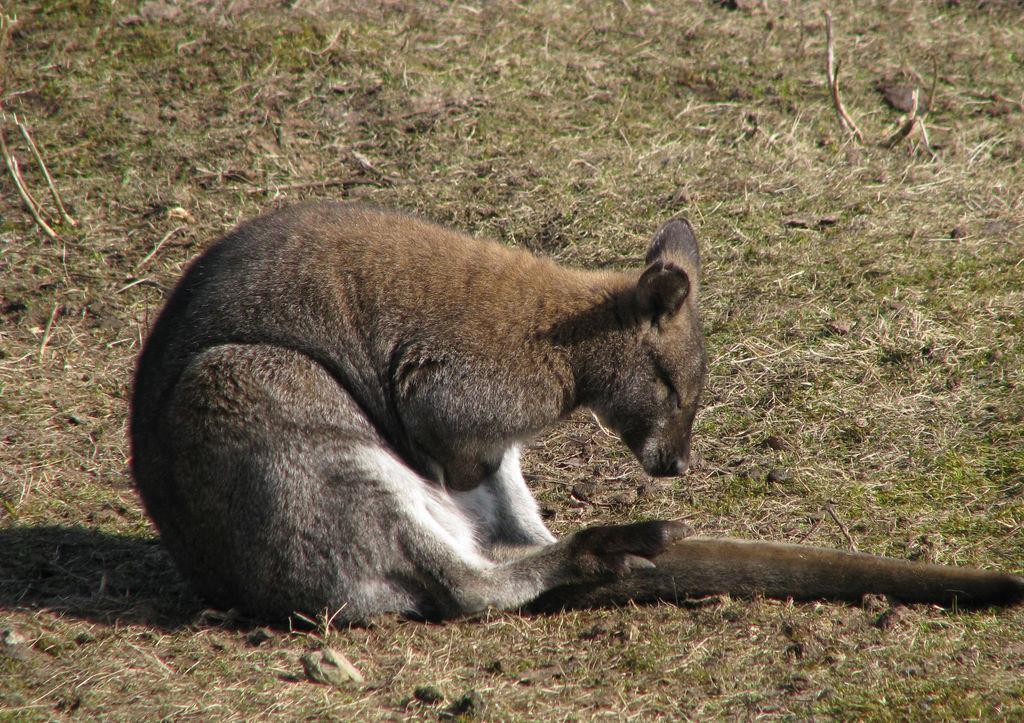Can you describe this image briefly? In this image, we can see an animal. We can see the ground covered with grass. 